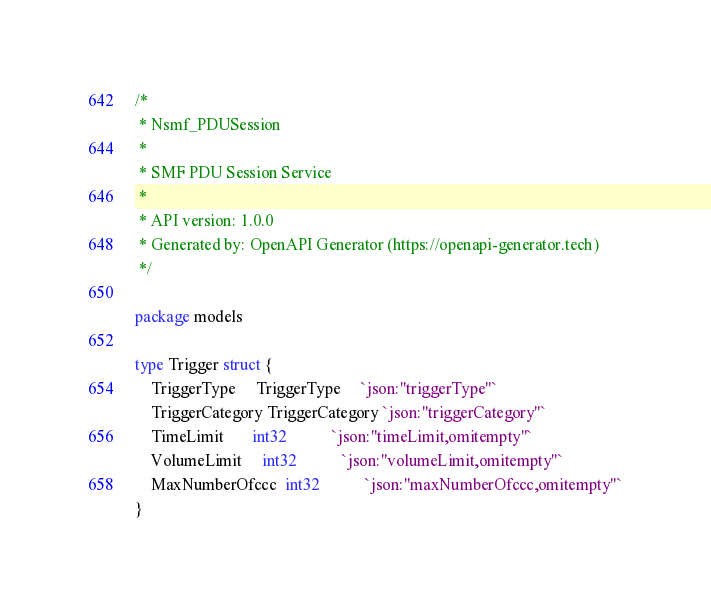Convert code to text. <code><loc_0><loc_0><loc_500><loc_500><_Go_>/*
 * Nsmf_PDUSession
 *
 * SMF PDU Session Service
 *
 * API version: 1.0.0
 * Generated by: OpenAPI Generator (https://openapi-generator.tech)
 */

package models

type Trigger struct {
	TriggerType     TriggerType     `json:"triggerType"`
	TriggerCategory TriggerCategory `json:"triggerCategory"`
	TimeLimit       int32           `json:"timeLimit,omitempty"`
	VolumeLimit     int32           `json:"volumeLimit,omitempty"`
	MaxNumberOfccc  int32           `json:"maxNumberOfccc,omitempty"`
}
</code> 